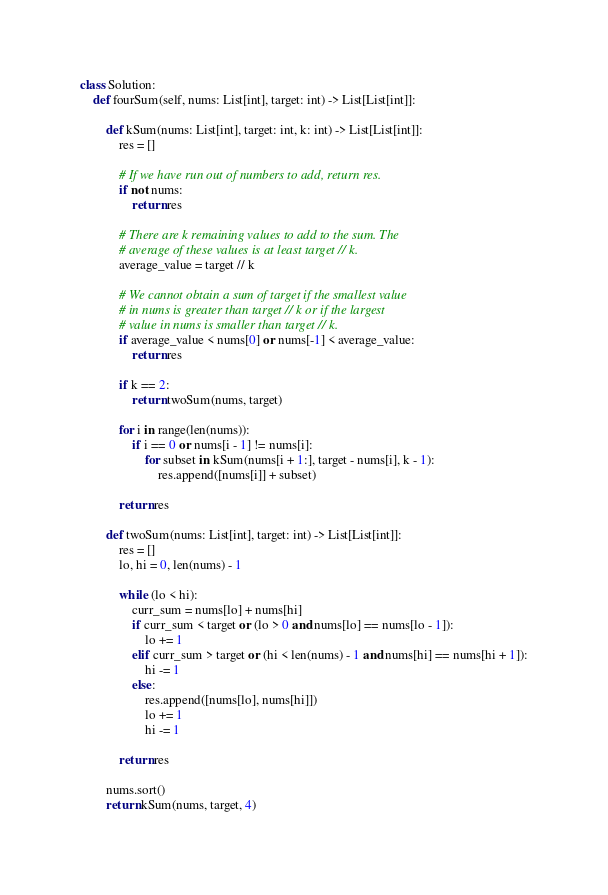<code> <loc_0><loc_0><loc_500><loc_500><_Python_>class Solution:
    def fourSum(self, nums: List[int], target: int) -> List[List[int]]:
	
        def kSum(nums: List[int], target: int, k: int) -> List[List[int]]:
            res = []
            
            # If we have run out of numbers to add, return res.
            if not nums:
                return res
            
            # There are k remaining values to add to the sum. The 
            # average of these values is at least target // k.
            average_value = target // k
            
            # We cannot obtain a sum of target if the smallest value
            # in nums is greater than target // k or if the largest 
            # value in nums is smaller than target // k.
            if average_value < nums[0] or nums[-1] < average_value:
                return res
            
            if k == 2:
                return twoSum(nums, target)
    
            for i in range(len(nums)):
                if i == 0 or nums[i - 1] != nums[i]:
                    for subset in kSum(nums[i + 1:], target - nums[i], k - 1):
                        res.append([nums[i]] + subset)
    
            return res

        def twoSum(nums: List[int], target: int) -> List[List[int]]:
            res = []
            lo, hi = 0, len(nums) - 1
    
            while (lo < hi):
                curr_sum = nums[lo] + nums[hi]
                if curr_sum < target or (lo > 0 and nums[lo] == nums[lo - 1]):
                    lo += 1
                elif curr_sum > target or (hi < len(nums) - 1 and nums[hi] == nums[hi + 1]):
                    hi -= 1
                else:
                    res.append([nums[lo], nums[hi]])
                    lo += 1
                    hi -= 1
                                                         
            return res

        nums.sort()
        return kSum(nums, target, 4)</code> 